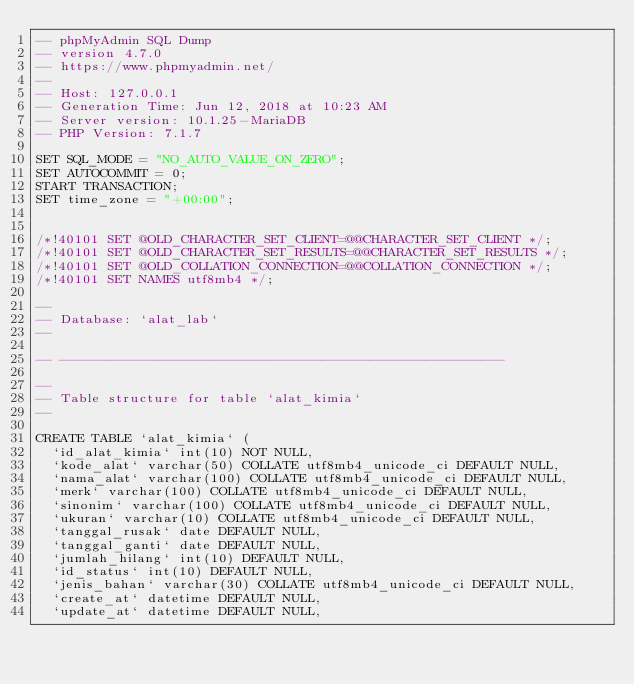Convert code to text. <code><loc_0><loc_0><loc_500><loc_500><_SQL_>-- phpMyAdmin SQL Dump
-- version 4.7.0
-- https://www.phpmyadmin.net/
--
-- Host: 127.0.0.1
-- Generation Time: Jun 12, 2018 at 10:23 AM
-- Server version: 10.1.25-MariaDB
-- PHP Version: 7.1.7

SET SQL_MODE = "NO_AUTO_VALUE_ON_ZERO";
SET AUTOCOMMIT = 0;
START TRANSACTION;
SET time_zone = "+00:00";


/*!40101 SET @OLD_CHARACTER_SET_CLIENT=@@CHARACTER_SET_CLIENT */;
/*!40101 SET @OLD_CHARACTER_SET_RESULTS=@@CHARACTER_SET_RESULTS */;
/*!40101 SET @OLD_COLLATION_CONNECTION=@@COLLATION_CONNECTION */;
/*!40101 SET NAMES utf8mb4 */;

--
-- Database: `alat_lab`
--

-- --------------------------------------------------------

--
-- Table structure for table `alat_kimia`
--

CREATE TABLE `alat_kimia` (
  `id_alat_kimia` int(10) NOT NULL,
  `kode_alat` varchar(50) COLLATE utf8mb4_unicode_ci DEFAULT NULL,
  `nama_alat` varchar(100) COLLATE utf8mb4_unicode_ci DEFAULT NULL,
  `merk` varchar(100) COLLATE utf8mb4_unicode_ci DEFAULT NULL,
  `sinonim` varchar(100) COLLATE utf8mb4_unicode_ci DEFAULT NULL,
  `ukuran` varchar(10) COLLATE utf8mb4_unicode_ci DEFAULT NULL,
  `tanggal_rusak` date DEFAULT NULL,
  `tanggal_ganti` date DEFAULT NULL,
  `jumlah_hilang` int(10) DEFAULT NULL,
  `id_status` int(10) DEFAULT NULL,
  `jenis_bahan` varchar(30) COLLATE utf8mb4_unicode_ci DEFAULT NULL,
  `create_at` datetime DEFAULT NULL,
  `update_at` datetime DEFAULT NULL,</code> 